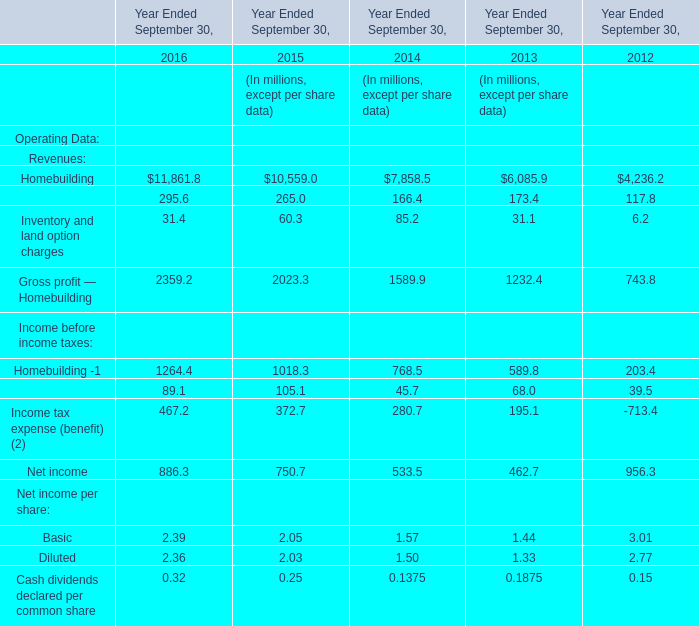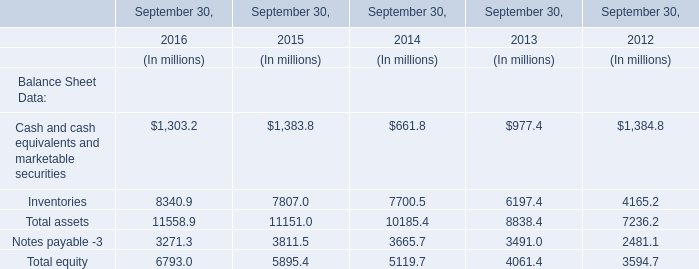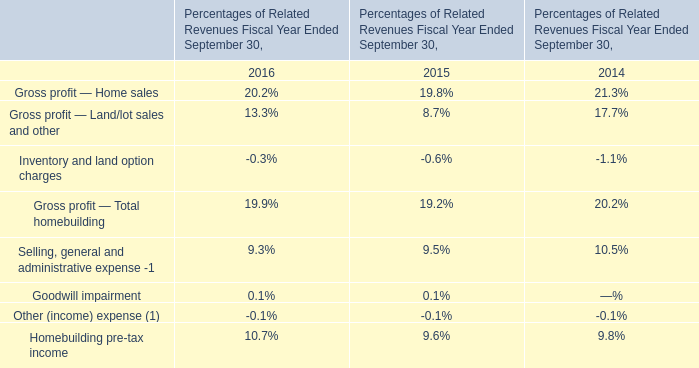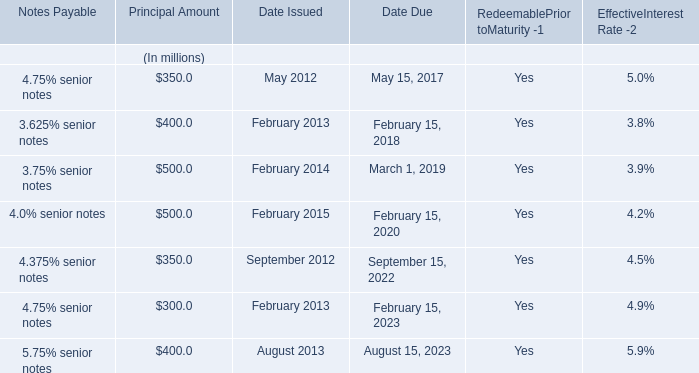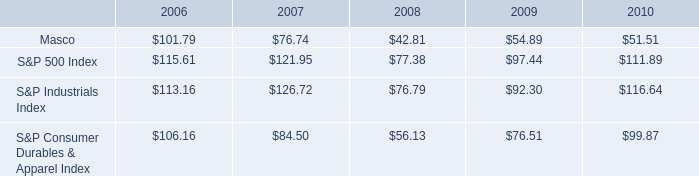what was the percent of the increase in the s&p industrial index from 2006 to 2007 
Computations: ((126.72 - 113.16) / 113.16)
Answer: 0.11983. 